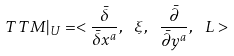<formula> <loc_0><loc_0><loc_500><loc_500>T T M | _ { U } = < \frac { \bar { \delta } } { \bar { \delta } x ^ { a } } , \ \xi , \ \frac { \bar { \partial } } { \bar { \partial } y ^ { a } } , \ L ></formula> 